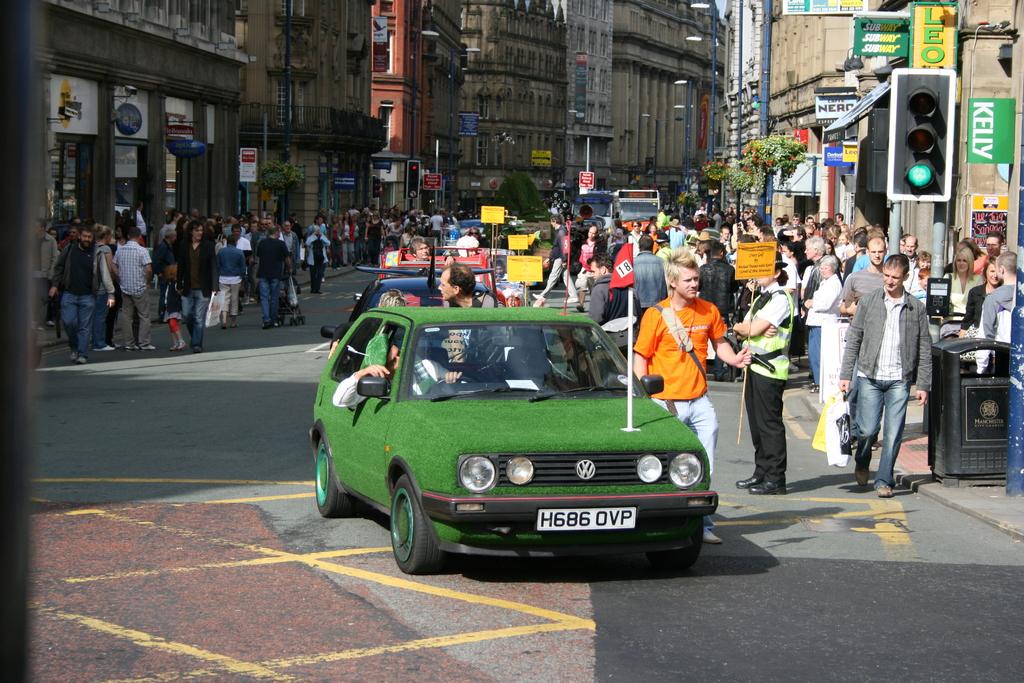What does it say on the green sign to the right of the traffic light?
Your response must be concise. Kelly. What is the license plate?
Offer a very short reply. H686 ovp. 